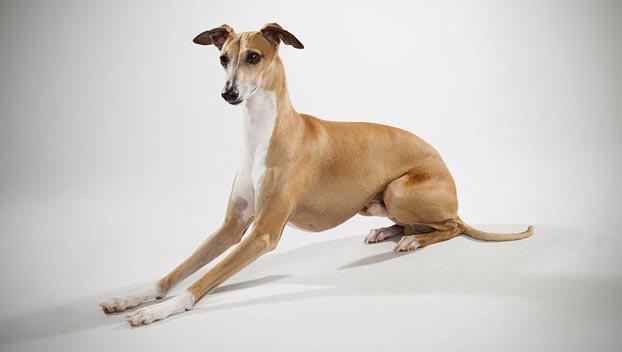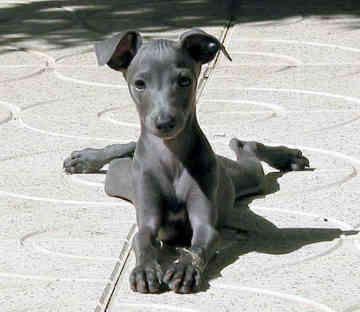The first image is the image on the left, the second image is the image on the right. Given the left and right images, does the statement "All dog legs are visible and no dog is sitting or laying down." hold true? Answer yes or no. No. 